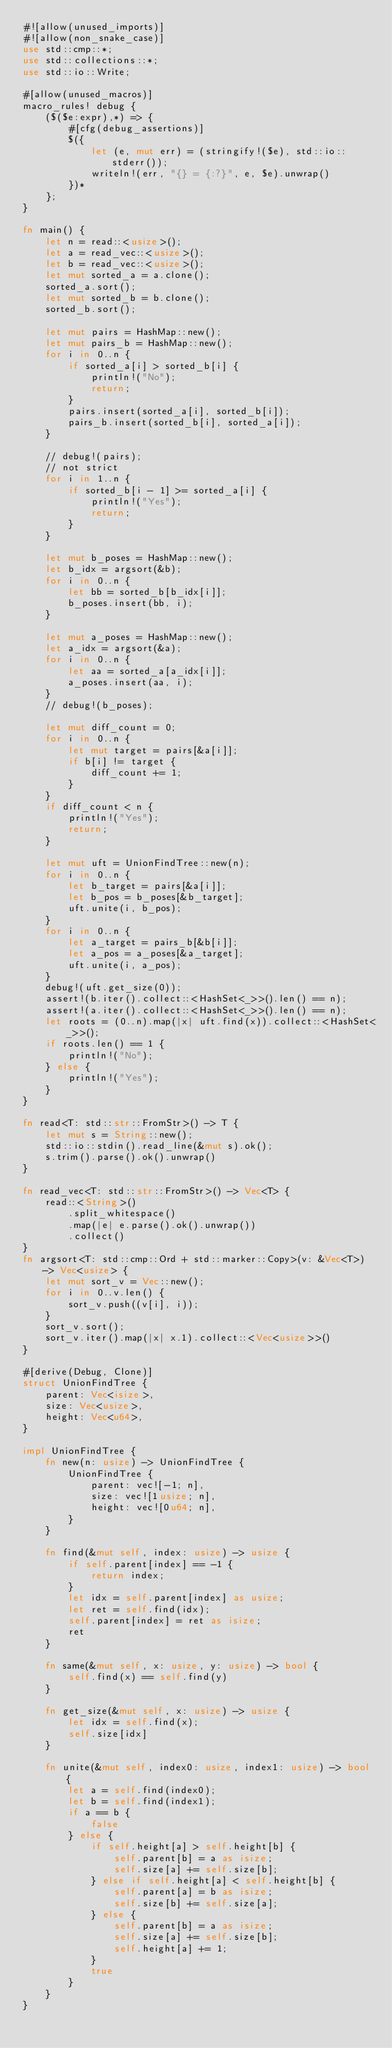Convert code to text. <code><loc_0><loc_0><loc_500><loc_500><_Rust_>#![allow(unused_imports)]
#![allow(non_snake_case)]
use std::cmp::*;
use std::collections::*;
use std::io::Write;

#[allow(unused_macros)]
macro_rules! debug {
    ($($e:expr),*) => {
        #[cfg(debug_assertions)]
        $({
            let (e, mut err) = (stringify!($e), std::io::stderr());
            writeln!(err, "{} = {:?}", e, $e).unwrap()
        })*
    };
}

fn main() {
    let n = read::<usize>();
    let a = read_vec::<usize>();
    let b = read_vec::<usize>();
    let mut sorted_a = a.clone();
    sorted_a.sort();
    let mut sorted_b = b.clone();
    sorted_b.sort();

    let mut pairs = HashMap::new();
    let mut pairs_b = HashMap::new();
    for i in 0..n {
        if sorted_a[i] > sorted_b[i] {
            println!("No");
            return;
        }
        pairs.insert(sorted_a[i], sorted_b[i]);
        pairs_b.insert(sorted_b[i], sorted_a[i]);
    }

    // debug!(pairs);
    // not strict
    for i in 1..n {
        if sorted_b[i - 1] >= sorted_a[i] {
            println!("Yes");
            return;
        }
    }

    let mut b_poses = HashMap::new();
    let b_idx = argsort(&b);
    for i in 0..n {
        let bb = sorted_b[b_idx[i]];
        b_poses.insert(bb, i);
    }

    let mut a_poses = HashMap::new();
    let a_idx = argsort(&a);
    for i in 0..n {
        let aa = sorted_a[a_idx[i]];
        a_poses.insert(aa, i);
    }
    // debug!(b_poses);

    let mut diff_count = 0;
    for i in 0..n {
        let mut target = pairs[&a[i]];
        if b[i] != target {
            diff_count += 1;
        }
    }
    if diff_count < n {
        println!("Yes");
        return;
    }

    let mut uft = UnionFindTree::new(n);
    for i in 0..n {
        let b_target = pairs[&a[i]];
        let b_pos = b_poses[&b_target];
        uft.unite(i, b_pos);
    }
    for i in 0..n {
        let a_target = pairs_b[&b[i]];
        let a_pos = a_poses[&a_target];
        uft.unite(i, a_pos);
    }
    debug!(uft.get_size(0));
    assert!(b.iter().collect::<HashSet<_>>().len() == n);
    assert!(a.iter().collect::<HashSet<_>>().len() == n);
    let roots = (0..n).map(|x| uft.find(x)).collect::<HashSet<_>>();
    if roots.len() == 1 {
        println!("No");
    } else {
        println!("Yes");
    }
}

fn read<T: std::str::FromStr>() -> T {
    let mut s = String::new();
    std::io::stdin().read_line(&mut s).ok();
    s.trim().parse().ok().unwrap()
}

fn read_vec<T: std::str::FromStr>() -> Vec<T> {
    read::<String>()
        .split_whitespace()
        .map(|e| e.parse().ok().unwrap())
        .collect()
}
fn argsort<T: std::cmp::Ord + std::marker::Copy>(v: &Vec<T>) -> Vec<usize> {
    let mut sort_v = Vec::new();
    for i in 0..v.len() {
        sort_v.push((v[i], i));
    }
    sort_v.sort();
    sort_v.iter().map(|x| x.1).collect::<Vec<usize>>()
}

#[derive(Debug, Clone)]
struct UnionFindTree {
    parent: Vec<isize>,
    size: Vec<usize>,
    height: Vec<u64>,
}

impl UnionFindTree {
    fn new(n: usize) -> UnionFindTree {
        UnionFindTree {
            parent: vec![-1; n],
            size: vec![1usize; n],
            height: vec![0u64; n],
        }
    }

    fn find(&mut self, index: usize) -> usize {
        if self.parent[index] == -1 {
            return index;
        }
        let idx = self.parent[index] as usize;
        let ret = self.find(idx);
        self.parent[index] = ret as isize;
        ret
    }

    fn same(&mut self, x: usize, y: usize) -> bool {
        self.find(x) == self.find(y)
    }

    fn get_size(&mut self, x: usize) -> usize {
        let idx = self.find(x);
        self.size[idx]
    }

    fn unite(&mut self, index0: usize, index1: usize) -> bool {
        let a = self.find(index0);
        let b = self.find(index1);
        if a == b {
            false
        } else {
            if self.height[a] > self.height[b] {
                self.parent[b] = a as isize;
                self.size[a] += self.size[b];
            } else if self.height[a] < self.height[b] {
                self.parent[a] = b as isize;
                self.size[b] += self.size[a];
            } else {
                self.parent[b] = a as isize;
                self.size[a] += self.size[b];
                self.height[a] += 1;
            }
            true
        }
    }
}
</code> 